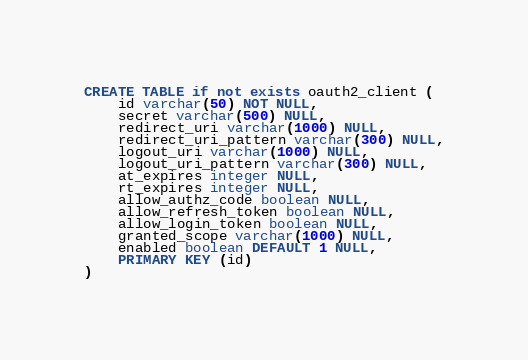<code> <loc_0><loc_0><loc_500><loc_500><_SQL_>CREATE TABLE if not exists oauth2_client (
    id varchar(50) NOT NULL,
    secret varchar(500) NULL,
    redirect_uri varchar(1000) NULL,
    redirect_uri_pattern varchar(300) NULL,
    logout_uri varchar(1000) NULL,
    logout_uri_pattern varchar(300) NULL,
    at_expires integer NULL,
    rt_expires integer NULL,
    allow_authz_code boolean NULL,
    allow_refresh_token boolean NULL,
    allow_login_token boolean NULL,
    granted_scope varchar(1000) NULL,
    enabled boolean DEFAULT 1 NULL,
    PRIMARY KEY (id)
)</code> 